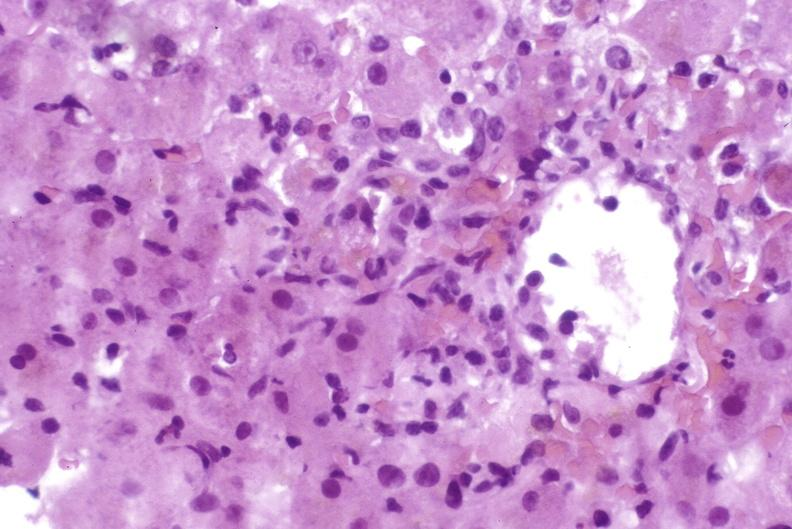what does this image show?
Answer the question using a single word or phrase. Moderate acute rejection 